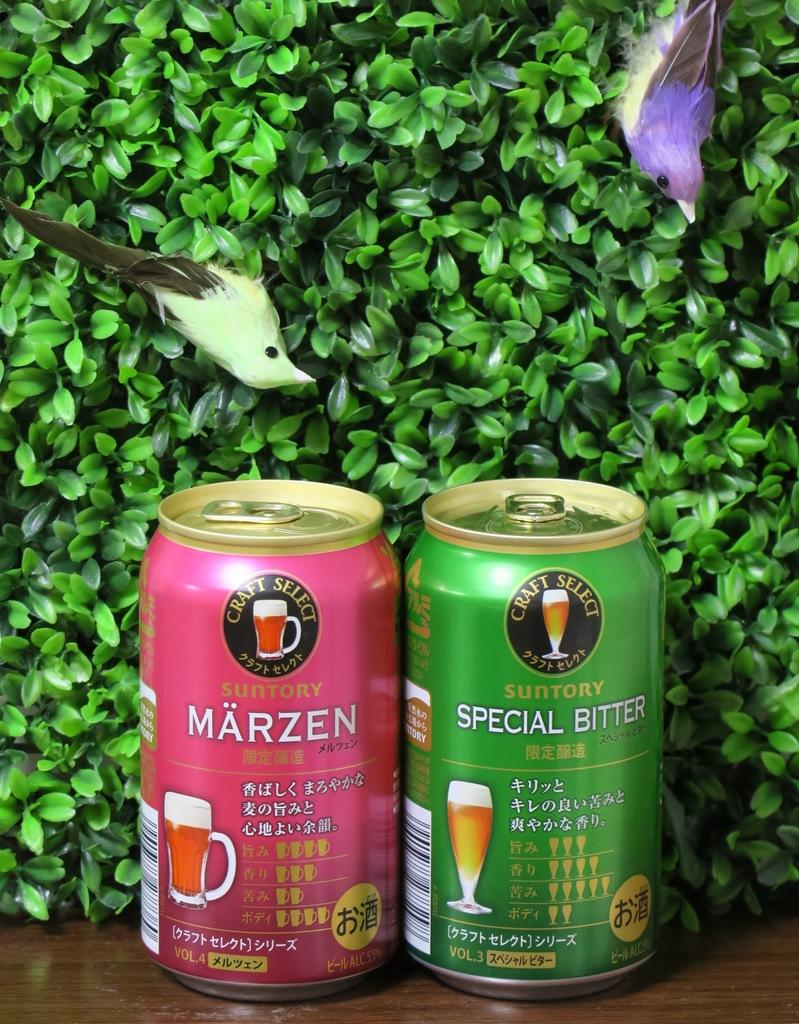<image>
Describe the image concisely. Two Craft Select branded drinks are sitting next to each other in different colored cans. 